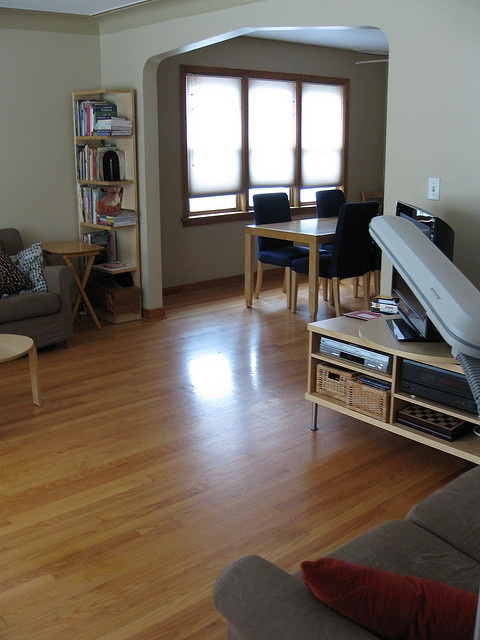Describe the objects in this image and their specific colors. I can see couch in gray and black tones, chair in gray and black tones, chair in gray, black, and maroon tones, dining table in gray, olive, black, and darkgray tones, and tv in gray, black, and blue tones in this image. 